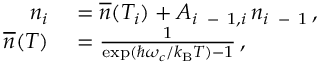Convert formula to latex. <formula><loc_0><loc_0><loc_500><loc_500>\begin{array} { r l } { n _ { i } } & = \overline { n } ( T _ { i } ) + A _ { i \, - 1 , i } \, n _ { i \, - 1 } \, , } \\ { \overline { n } ( T ) } & = \frac { 1 } { \exp ( \hbar { \omega } _ { c } / k _ { B } T ) - 1 } \, , } \end{array}</formula> 